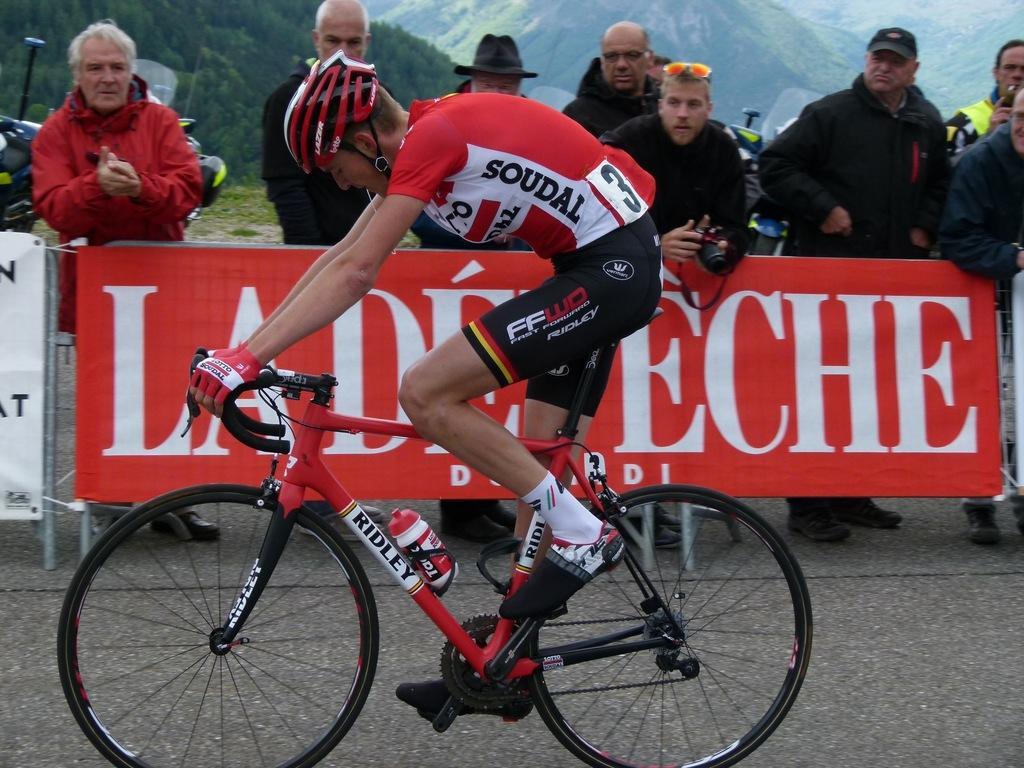Can you describe this image briefly? This picture is clicked outside. In the foreground there is a person wearing red color t-shirt, helmet and riding a bicycle and we can see the group of people standing on the ground and there is a red color banner on which the text is printed. In the background we can see the hills and some vehicles. 